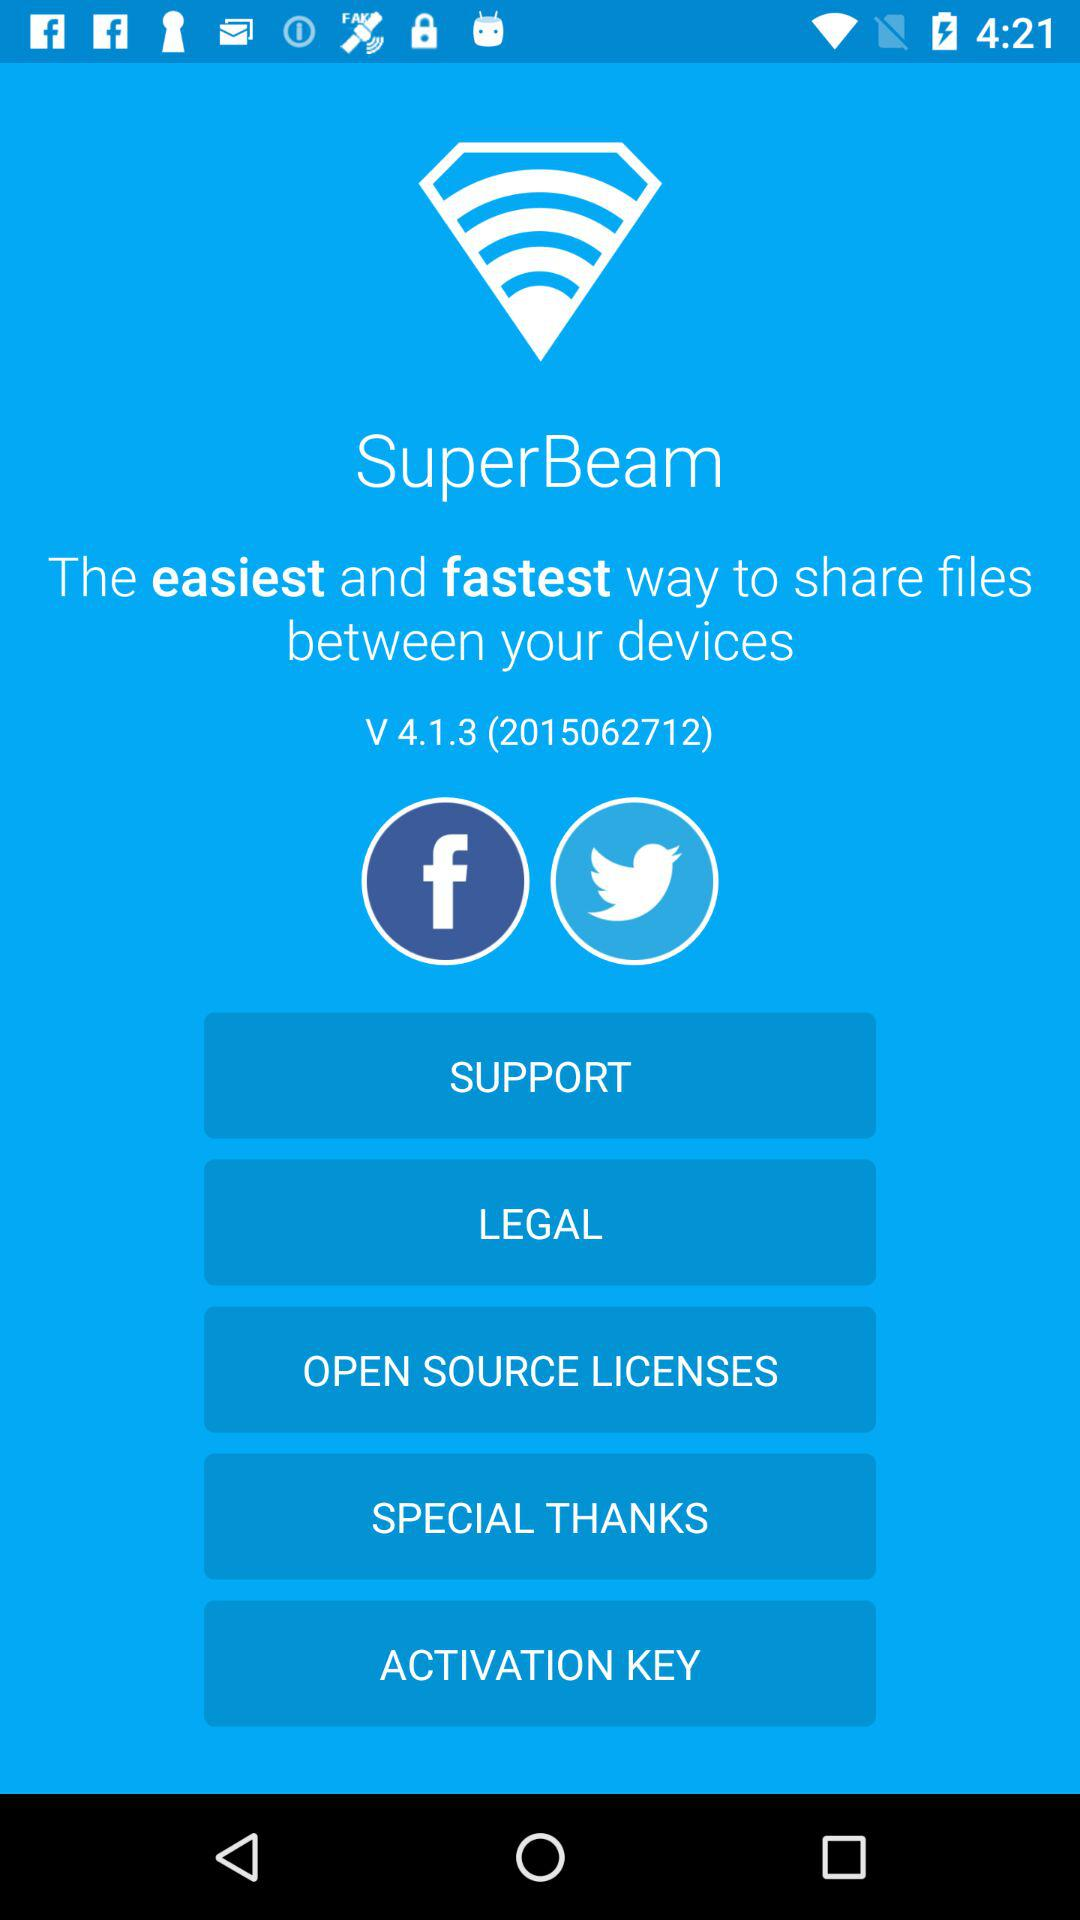How many notifications are there in "LEGAL"?
When the provided information is insufficient, respond with <no answer>. <no answer> 